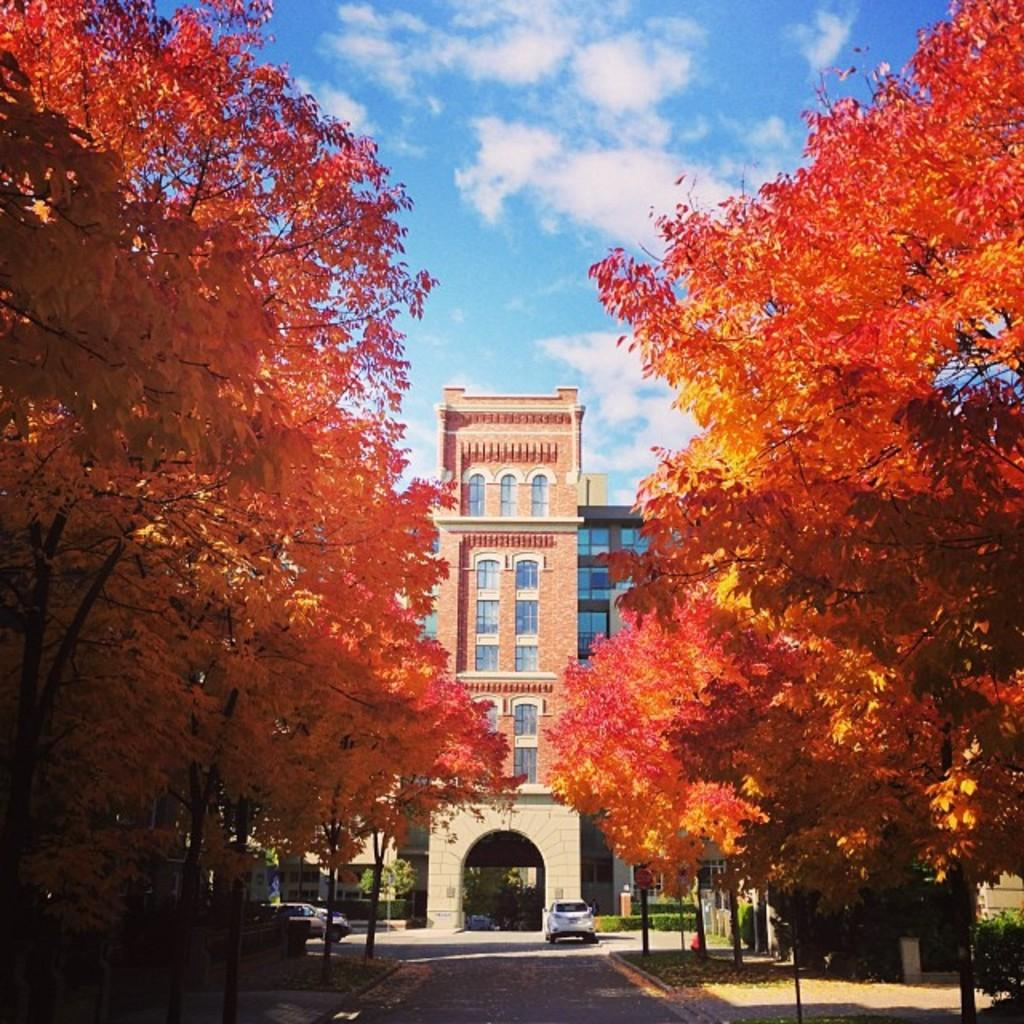What type of structure is visible in the image? There is a building with windows in the image. What else can be seen on the ground in the image? There are vehicles on the pathway in the image. Are there any natural elements present in the image? Yes, there are plants and a group of trees in the image. What is the condition of the sky in the image? The sky is visible in the image and appears cloudy. How many sisters are playing with the pipe in the sand in the image? There is no pipe, sand, or sisters present in the image. 